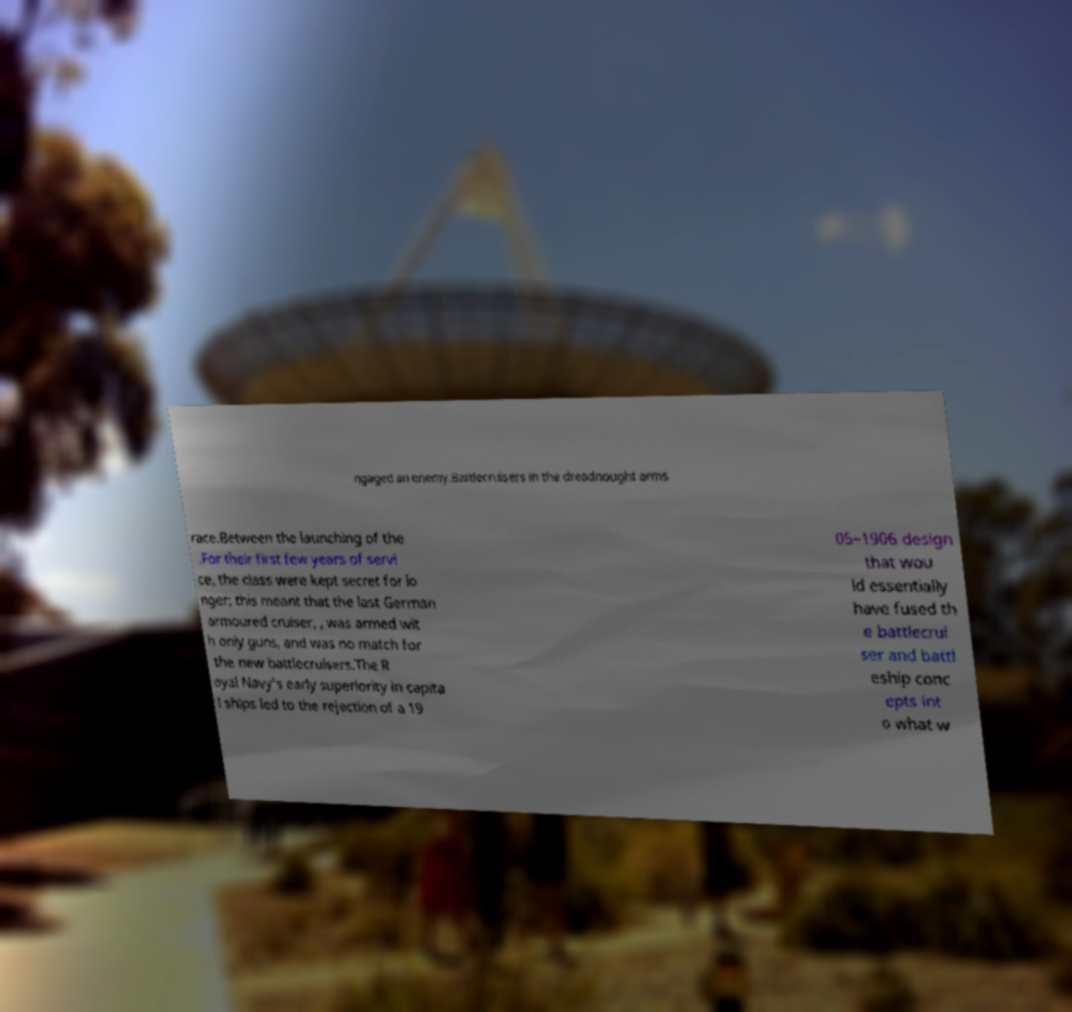Can you read and provide the text displayed in the image?This photo seems to have some interesting text. Can you extract and type it out for me? ngaged an enemy.Battlecruisers in the dreadnought arms race.Between the launching of the .For their first few years of servi ce, the class were kept secret for lo nger; this meant that the last German armoured cruiser, , was armed wit h only guns, and was no match for the new battlecruisers.The R oyal Navy's early superiority in capita l ships led to the rejection of a 19 05–1906 design that wou ld essentially have fused th e battlecrui ser and battl eship conc epts int o what w 